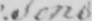Can you tell me what this handwritten text says? : sons 